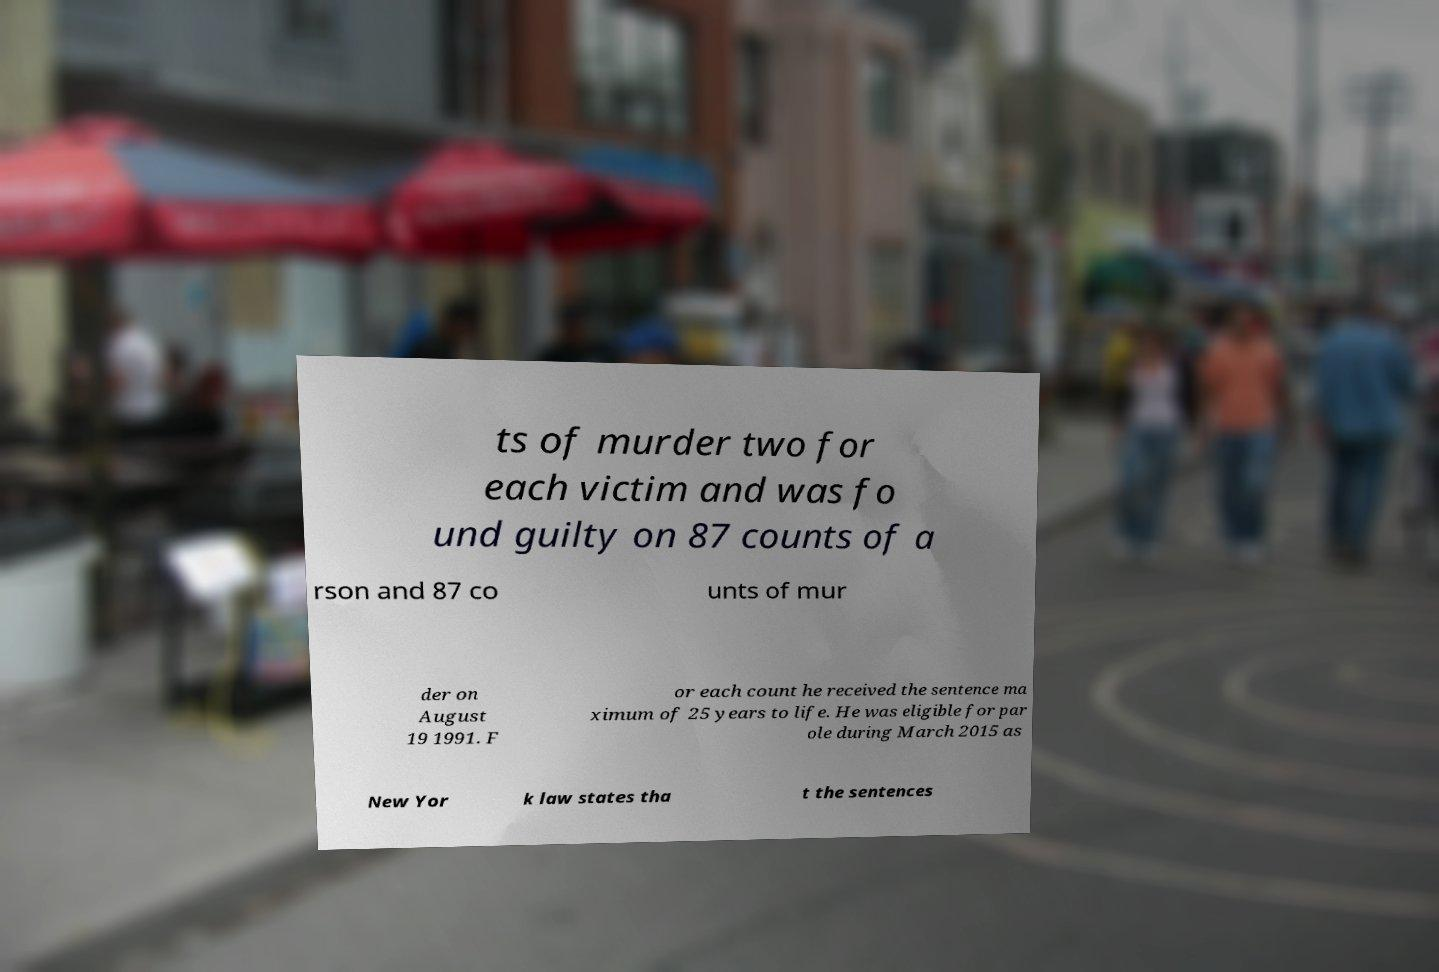What messages or text are displayed in this image? I need them in a readable, typed format. ts of murder two for each victim and was fo und guilty on 87 counts of a rson and 87 co unts of mur der on August 19 1991. F or each count he received the sentence ma ximum of 25 years to life. He was eligible for par ole during March 2015 as New Yor k law states tha t the sentences 